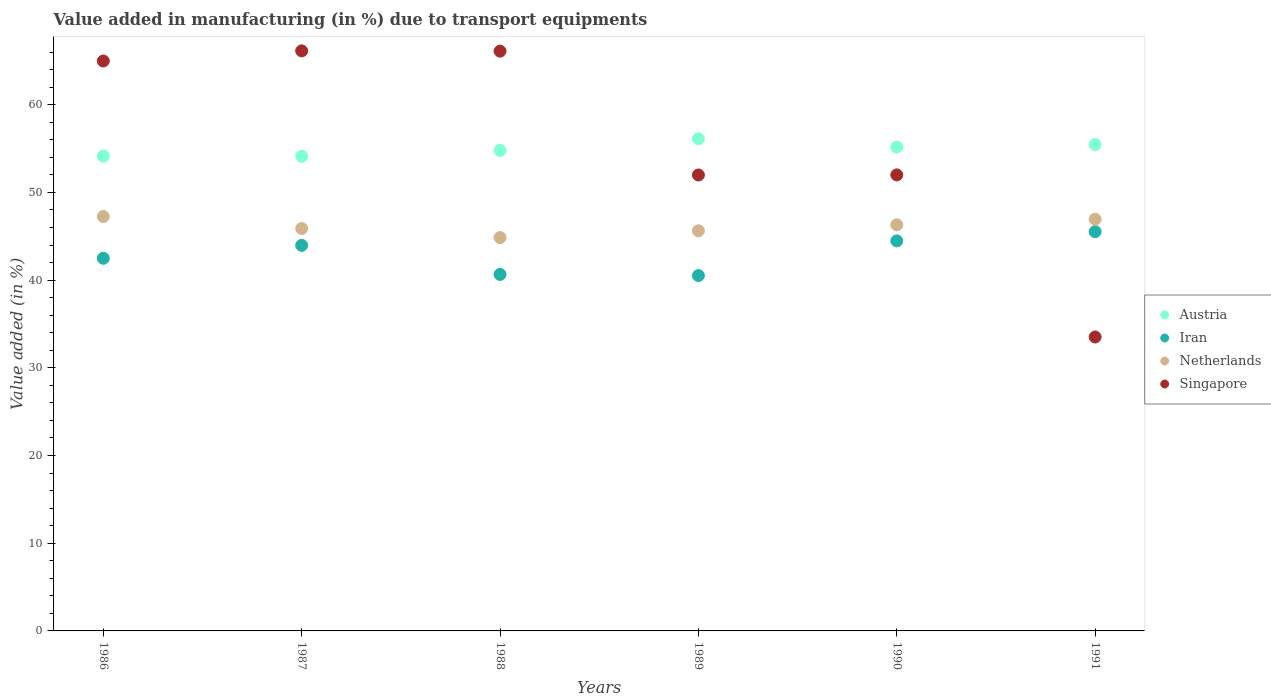What is the percentage of value added in manufacturing due to transport equipments in Austria in 1988?
Ensure brevity in your answer.  54.79. Across all years, what is the maximum percentage of value added in manufacturing due to transport equipments in Netherlands?
Give a very brief answer. 47.25. Across all years, what is the minimum percentage of value added in manufacturing due to transport equipments in Singapore?
Your answer should be compact. 33.51. What is the total percentage of value added in manufacturing due to transport equipments in Netherlands in the graph?
Provide a succinct answer. 276.85. What is the difference between the percentage of value added in manufacturing due to transport equipments in Iran in 1988 and that in 1991?
Your response must be concise. -4.87. What is the difference between the percentage of value added in manufacturing due to transport equipments in Netherlands in 1991 and the percentage of value added in manufacturing due to transport equipments in Iran in 1989?
Provide a succinct answer. 6.42. What is the average percentage of value added in manufacturing due to transport equipments in Iran per year?
Your response must be concise. 42.94. In the year 1986, what is the difference between the percentage of value added in manufacturing due to transport equipments in Singapore and percentage of value added in manufacturing due to transport equipments in Austria?
Give a very brief answer. 10.84. What is the ratio of the percentage of value added in manufacturing due to transport equipments in Singapore in 1989 to that in 1991?
Give a very brief answer. 1.55. Is the percentage of value added in manufacturing due to transport equipments in Netherlands in 1987 less than that in 1989?
Offer a very short reply. No. What is the difference between the highest and the second highest percentage of value added in manufacturing due to transport equipments in Netherlands?
Provide a succinct answer. 0.32. What is the difference between the highest and the lowest percentage of value added in manufacturing due to transport equipments in Singapore?
Ensure brevity in your answer.  32.62. Is the sum of the percentage of value added in manufacturing due to transport equipments in Netherlands in 1986 and 1989 greater than the maximum percentage of value added in manufacturing due to transport equipments in Austria across all years?
Offer a very short reply. Yes. Is it the case that in every year, the sum of the percentage of value added in manufacturing due to transport equipments in Netherlands and percentage of value added in manufacturing due to transport equipments in Singapore  is greater than the sum of percentage of value added in manufacturing due to transport equipments in Iran and percentage of value added in manufacturing due to transport equipments in Austria?
Your answer should be compact. No. Is it the case that in every year, the sum of the percentage of value added in manufacturing due to transport equipments in Netherlands and percentage of value added in manufacturing due to transport equipments in Austria  is greater than the percentage of value added in manufacturing due to transport equipments in Singapore?
Offer a very short reply. Yes. Is the percentage of value added in manufacturing due to transport equipments in Austria strictly less than the percentage of value added in manufacturing due to transport equipments in Netherlands over the years?
Give a very brief answer. No. How many dotlines are there?
Your response must be concise. 4. What is the difference between two consecutive major ticks on the Y-axis?
Offer a terse response. 10. Does the graph contain any zero values?
Offer a very short reply. No. How are the legend labels stacked?
Give a very brief answer. Vertical. What is the title of the graph?
Provide a succinct answer. Value added in manufacturing (in %) due to transport equipments. Does "High income" appear as one of the legend labels in the graph?
Your answer should be very brief. No. What is the label or title of the X-axis?
Provide a short and direct response. Years. What is the label or title of the Y-axis?
Keep it short and to the point. Value added (in %). What is the Value added (in %) of Austria in 1986?
Your answer should be very brief. 54.14. What is the Value added (in %) of Iran in 1986?
Ensure brevity in your answer.  42.49. What is the Value added (in %) of Netherlands in 1986?
Offer a terse response. 47.25. What is the Value added (in %) of Singapore in 1986?
Give a very brief answer. 64.98. What is the Value added (in %) of Austria in 1987?
Provide a succinct answer. 54.12. What is the Value added (in %) in Iran in 1987?
Your response must be concise. 43.96. What is the Value added (in %) of Netherlands in 1987?
Make the answer very short. 45.88. What is the Value added (in %) of Singapore in 1987?
Ensure brevity in your answer.  66.14. What is the Value added (in %) in Austria in 1988?
Your answer should be compact. 54.79. What is the Value added (in %) of Iran in 1988?
Your answer should be very brief. 40.65. What is the Value added (in %) in Netherlands in 1988?
Make the answer very short. 44.85. What is the Value added (in %) in Singapore in 1988?
Your response must be concise. 66.11. What is the Value added (in %) of Austria in 1989?
Offer a terse response. 56.11. What is the Value added (in %) of Iran in 1989?
Provide a short and direct response. 40.52. What is the Value added (in %) of Netherlands in 1989?
Your answer should be compact. 45.63. What is the Value added (in %) of Singapore in 1989?
Make the answer very short. 51.99. What is the Value added (in %) in Austria in 1990?
Offer a terse response. 55.17. What is the Value added (in %) of Iran in 1990?
Your response must be concise. 44.48. What is the Value added (in %) of Netherlands in 1990?
Make the answer very short. 46.31. What is the Value added (in %) of Singapore in 1990?
Your answer should be compact. 52. What is the Value added (in %) of Austria in 1991?
Offer a terse response. 55.46. What is the Value added (in %) of Iran in 1991?
Ensure brevity in your answer.  45.52. What is the Value added (in %) of Netherlands in 1991?
Your answer should be very brief. 46.94. What is the Value added (in %) of Singapore in 1991?
Make the answer very short. 33.51. Across all years, what is the maximum Value added (in %) in Austria?
Your response must be concise. 56.11. Across all years, what is the maximum Value added (in %) in Iran?
Offer a very short reply. 45.52. Across all years, what is the maximum Value added (in %) in Netherlands?
Provide a succinct answer. 47.25. Across all years, what is the maximum Value added (in %) of Singapore?
Make the answer very short. 66.14. Across all years, what is the minimum Value added (in %) of Austria?
Offer a terse response. 54.12. Across all years, what is the minimum Value added (in %) of Iran?
Make the answer very short. 40.52. Across all years, what is the minimum Value added (in %) of Netherlands?
Provide a succinct answer. 44.85. Across all years, what is the minimum Value added (in %) of Singapore?
Your answer should be very brief. 33.51. What is the total Value added (in %) of Austria in the graph?
Provide a short and direct response. 329.79. What is the total Value added (in %) of Iran in the graph?
Provide a succinct answer. 257.62. What is the total Value added (in %) in Netherlands in the graph?
Make the answer very short. 276.85. What is the total Value added (in %) in Singapore in the graph?
Give a very brief answer. 334.73. What is the difference between the Value added (in %) in Austria in 1986 and that in 1987?
Offer a terse response. 0.02. What is the difference between the Value added (in %) in Iran in 1986 and that in 1987?
Give a very brief answer. -1.47. What is the difference between the Value added (in %) in Netherlands in 1986 and that in 1987?
Offer a terse response. 1.37. What is the difference between the Value added (in %) in Singapore in 1986 and that in 1987?
Your answer should be very brief. -1.15. What is the difference between the Value added (in %) in Austria in 1986 and that in 1988?
Your answer should be very brief. -0.64. What is the difference between the Value added (in %) of Iran in 1986 and that in 1988?
Your answer should be compact. 1.84. What is the difference between the Value added (in %) of Netherlands in 1986 and that in 1988?
Make the answer very short. 2.41. What is the difference between the Value added (in %) in Singapore in 1986 and that in 1988?
Your answer should be very brief. -1.13. What is the difference between the Value added (in %) of Austria in 1986 and that in 1989?
Offer a terse response. -1.97. What is the difference between the Value added (in %) of Iran in 1986 and that in 1989?
Your response must be concise. 1.97. What is the difference between the Value added (in %) in Netherlands in 1986 and that in 1989?
Provide a succinct answer. 1.63. What is the difference between the Value added (in %) of Singapore in 1986 and that in 1989?
Provide a succinct answer. 13. What is the difference between the Value added (in %) of Austria in 1986 and that in 1990?
Provide a short and direct response. -1.03. What is the difference between the Value added (in %) in Iran in 1986 and that in 1990?
Your answer should be compact. -1.99. What is the difference between the Value added (in %) of Netherlands in 1986 and that in 1990?
Make the answer very short. 0.95. What is the difference between the Value added (in %) of Singapore in 1986 and that in 1990?
Keep it short and to the point. 12.99. What is the difference between the Value added (in %) in Austria in 1986 and that in 1991?
Ensure brevity in your answer.  -1.31. What is the difference between the Value added (in %) of Iran in 1986 and that in 1991?
Provide a succinct answer. -3.03. What is the difference between the Value added (in %) of Netherlands in 1986 and that in 1991?
Ensure brevity in your answer.  0.32. What is the difference between the Value added (in %) of Singapore in 1986 and that in 1991?
Give a very brief answer. 31.47. What is the difference between the Value added (in %) in Austria in 1987 and that in 1988?
Your answer should be very brief. -0.67. What is the difference between the Value added (in %) in Iran in 1987 and that in 1988?
Offer a terse response. 3.31. What is the difference between the Value added (in %) of Netherlands in 1987 and that in 1988?
Make the answer very short. 1.03. What is the difference between the Value added (in %) in Singapore in 1987 and that in 1988?
Offer a very short reply. 0.03. What is the difference between the Value added (in %) of Austria in 1987 and that in 1989?
Offer a terse response. -1.99. What is the difference between the Value added (in %) in Iran in 1987 and that in 1989?
Keep it short and to the point. 3.44. What is the difference between the Value added (in %) in Netherlands in 1987 and that in 1989?
Provide a short and direct response. 0.26. What is the difference between the Value added (in %) in Singapore in 1987 and that in 1989?
Offer a very short reply. 14.15. What is the difference between the Value added (in %) in Austria in 1987 and that in 1990?
Provide a succinct answer. -1.05. What is the difference between the Value added (in %) in Iran in 1987 and that in 1990?
Your response must be concise. -0.51. What is the difference between the Value added (in %) of Netherlands in 1987 and that in 1990?
Make the answer very short. -0.43. What is the difference between the Value added (in %) in Singapore in 1987 and that in 1990?
Provide a short and direct response. 14.14. What is the difference between the Value added (in %) of Austria in 1987 and that in 1991?
Give a very brief answer. -1.34. What is the difference between the Value added (in %) in Iran in 1987 and that in 1991?
Keep it short and to the point. -1.56. What is the difference between the Value added (in %) in Netherlands in 1987 and that in 1991?
Make the answer very short. -1.06. What is the difference between the Value added (in %) of Singapore in 1987 and that in 1991?
Provide a succinct answer. 32.62. What is the difference between the Value added (in %) of Austria in 1988 and that in 1989?
Keep it short and to the point. -1.32. What is the difference between the Value added (in %) of Iran in 1988 and that in 1989?
Give a very brief answer. 0.13. What is the difference between the Value added (in %) in Netherlands in 1988 and that in 1989?
Provide a succinct answer. -0.78. What is the difference between the Value added (in %) of Singapore in 1988 and that in 1989?
Offer a terse response. 14.12. What is the difference between the Value added (in %) of Austria in 1988 and that in 1990?
Ensure brevity in your answer.  -0.38. What is the difference between the Value added (in %) in Iran in 1988 and that in 1990?
Your answer should be compact. -3.83. What is the difference between the Value added (in %) in Netherlands in 1988 and that in 1990?
Make the answer very short. -1.46. What is the difference between the Value added (in %) in Singapore in 1988 and that in 1990?
Your answer should be compact. 14.11. What is the difference between the Value added (in %) in Austria in 1988 and that in 1991?
Your answer should be very brief. -0.67. What is the difference between the Value added (in %) of Iran in 1988 and that in 1991?
Give a very brief answer. -4.87. What is the difference between the Value added (in %) of Netherlands in 1988 and that in 1991?
Keep it short and to the point. -2.09. What is the difference between the Value added (in %) of Singapore in 1988 and that in 1991?
Your response must be concise. 32.6. What is the difference between the Value added (in %) in Austria in 1989 and that in 1990?
Give a very brief answer. 0.94. What is the difference between the Value added (in %) of Iran in 1989 and that in 1990?
Provide a succinct answer. -3.96. What is the difference between the Value added (in %) of Netherlands in 1989 and that in 1990?
Offer a very short reply. -0.68. What is the difference between the Value added (in %) in Singapore in 1989 and that in 1990?
Offer a terse response. -0.01. What is the difference between the Value added (in %) in Austria in 1989 and that in 1991?
Provide a succinct answer. 0.65. What is the difference between the Value added (in %) of Iran in 1989 and that in 1991?
Your answer should be very brief. -5. What is the difference between the Value added (in %) in Netherlands in 1989 and that in 1991?
Ensure brevity in your answer.  -1.31. What is the difference between the Value added (in %) in Singapore in 1989 and that in 1991?
Provide a succinct answer. 18.47. What is the difference between the Value added (in %) in Austria in 1990 and that in 1991?
Your response must be concise. -0.29. What is the difference between the Value added (in %) of Iran in 1990 and that in 1991?
Make the answer very short. -1.05. What is the difference between the Value added (in %) in Netherlands in 1990 and that in 1991?
Provide a short and direct response. -0.63. What is the difference between the Value added (in %) in Singapore in 1990 and that in 1991?
Make the answer very short. 18.48. What is the difference between the Value added (in %) of Austria in 1986 and the Value added (in %) of Iran in 1987?
Your response must be concise. 10.18. What is the difference between the Value added (in %) of Austria in 1986 and the Value added (in %) of Netherlands in 1987?
Your answer should be compact. 8.26. What is the difference between the Value added (in %) in Austria in 1986 and the Value added (in %) in Singapore in 1987?
Keep it short and to the point. -11.99. What is the difference between the Value added (in %) in Iran in 1986 and the Value added (in %) in Netherlands in 1987?
Your response must be concise. -3.39. What is the difference between the Value added (in %) of Iran in 1986 and the Value added (in %) of Singapore in 1987?
Provide a succinct answer. -23.65. What is the difference between the Value added (in %) in Netherlands in 1986 and the Value added (in %) in Singapore in 1987?
Offer a very short reply. -18.89. What is the difference between the Value added (in %) of Austria in 1986 and the Value added (in %) of Iran in 1988?
Ensure brevity in your answer.  13.49. What is the difference between the Value added (in %) of Austria in 1986 and the Value added (in %) of Netherlands in 1988?
Keep it short and to the point. 9.3. What is the difference between the Value added (in %) of Austria in 1986 and the Value added (in %) of Singapore in 1988?
Ensure brevity in your answer.  -11.97. What is the difference between the Value added (in %) in Iran in 1986 and the Value added (in %) in Netherlands in 1988?
Provide a succinct answer. -2.36. What is the difference between the Value added (in %) of Iran in 1986 and the Value added (in %) of Singapore in 1988?
Your response must be concise. -23.62. What is the difference between the Value added (in %) in Netherlands in 1986 and the Value added (in %) in Singapore in 1988?
Your answer should be very brief. -18.86. What is the difference between the Value added (in %) in Austria in 1986 and the Value added (in %) in Iran in 1989?
Your answer should be very brief. 13.63. What is the difference between the Value added (in %) in Austria in 1986 and the Value added (in %) in Netherlands in 1989?
Your answer should be compact. 8.52. What is the difference between the Value added (in %) of Austria in 1986 and the Value added (in %) of Singapore in 1989?
Give a very brief answer. 2.16. What is the difference between the Value added (in %) in Iran in 1986 and the Value added (in %) in Netherlands in 1989?
Offer a very short reply. -3.14. What is the difference between the Value added (in %) of Iran in 1986 and the Value added (in %) of Singapore in 1989?
Provide a succinct answer. -9.5. What is the difference between the Value added (in %) in Netherlands in 1986 and the Value added (in %) in Singapore in 1989?
Give a very brief answer. -4.73. What is the difference between the Value added (in %) of Austria in 1986 and the Value added (in %) of Iran in 1990?
Keep it short and to the point. 9.67. What is the difference between the Value added (in %) in Austria in 1986 and the Value added (in %) in Netherlands in 1990?
Offer a very short reply. 7.84. What is the difference between the Value added (in %) in Austria in 1986 and the Value added (in %) in Singapore in 1990?
Offer a terse response. 2.15. What is the difference between the Value added (in %) in Iran in 1986 and the Value added (in %) in Netherlands in 1990?
Offer a very short reply. -3.82. What is the difference between the Value added (in %) in Iran in 1986 and the Value added (in %) in Singapore in 1990?
Offer a very short reply. -9.51. What is the difference between the Value added (in %) in Netherlands in 1986 and the Value added (in %) in Singapore in 1990?
Provide a succinct answer. -4.75. What is the difference between the Value added (in %) of Austria in 1986 and the Value added (in %) of Iran in 1991?
Your response must be concise. 8.62. What is the difference between the Value added (in %) of Austria in 1986 and the Value added (in %) of Netherlands in 1991?
Ensure brevity in your answer.  7.21. What is the difference between the Value added (in %) in Austria in 1986 and the Value added (in %) in Singapore in 1991?
Offer a terse response. 20.63. What is the difference between the Value added (in %) in Iran in 1986 and the Value added (in %) in Netherlands in 1991?
Make the answer very short. -4.45. What is the difference between the Value added (in %) of Iran in 1986 and the Value added (in %) of Singapore in 1991?
Offer a terse response. 8.97. What is the difference between the Value added (in %) in Netherlands in 1986 and the Value added (in %) in Singapore in 1991?
Provide a short and direct response. 13.74. What is the difference between the Value added (in %) of Austria in 1987 and the Value added (in %) of Iran in 1988?
Make the answer very short. 13.47. What is the difference between the Value added (in %) in Austria in 1987 and the Value added (in %) in Netherlands in 1988?
Your response must be concise. 9.27. What is the difference between the Value added (in %) of Austria in 1987 and the Value added (in %) of Singapore in 1988?
Your response must be concise. -11.99. What is the difference between the Value added (in %) of Iran in 1987 and the Value added (in %) of Netherlands in 1988?
Provide a short and direct response. -0.89. What is the difference between the Value added (in %) of Iran in 1987 and the Value added (in %) of Singapore in 1988?
Give a very brief answer. -22.15. What is the difference between the Value added (in %) of Netherlands in 1987 and the Value added (in %) of Singapore in 1988?
Offer a very short reply. -20.23. What is the difference between the Value added (in %) in Austria in 1987 and the Value added (in %) in Iran in 1989?
Make the answer very short. 13.6. What is the difference between the Value added (in %) in Austria in 1987 and the Value added (in %) in Netherlands in 1989?
Provide a succinct answer. 8.5. What is the difference between the Value added (in %) of Austria in 1987 and the Value added (in %) of Singapore in 1989?
Ensure brevity in your answer.  2.13. What is the difference between the Value added (in %) of Iran in 1987 and the Value added (in %) of Netherlands in 1989?
Offer a very short reply. -1.66. What is the difference between the Value added (in %) in Iran in 1987 and the Value added (in %) in Singapore in 1989?
Offer a terse response. -8.02. What is the difference between the Value added (in %) in Netherlands in 1987 and the Value added (in %) in Singapore in 1989?
Offer a very short reply. -6.11. What is the difference between the Value added (in %) of Austria in 1987 and the Value added (in %) of Iran in 1990?
Your answer should be very brief. 9.65. What is the difference between the Value added (in %) in Austria in 1987 and the Value added (in %) in Netherlands in 1990?
Your response must be concise. 7.81. What is the difference between the Value added (in %) of Austria in 1987 and the Value added (in %) of Singapore in 1990?
Make the answer very short. 2.12. What is the difference between the Value added (in %) of Iran in 1987 and the Value added (in %) of Netherlands in 1990?
Provide a short and direct response. -2.34. What is the difference between the Value added (in %) of Iran in 1987 and the Value added (in %) of Singapore in 1990?
Ensure brevity in your answer.  -8.04. What is the difference between the Value added (in %) in Netherlands in 1987 and the Value added (in %) in Singapore in 1990?
Your answer should be compact. -6.12. What is the difference between the Value added (in %) in Austria in 1987 and the Value added (in %) in Iran in 1991?
Your response must be concise. 8.6. What is the difference between the Value added (in %) in Austria in 1987 and the Value added (in %) in Netherlands in 1991?
Your answer should be very brief. 7.18. What is the difference between the Value added (in %) of Austria in 1987 and the Value added (in %) of Singapore in 1991?
Provide a short and direct response. 20.61. What is the difference between the Value added (in %) in Iran in 1987 and the Value added (in %) in Netherlands in 1991?
Offer a terse response. -2.97. What is the difference between the Value added (in %) in Iran in 1987 and the Value added (in %) in Singapore in 1991?
Your answer should be very brief. 10.45. What is the difference between the Value added (in %) of Netherlands in 1987 and the Value added (in %) of Singapore in 1991?
Ensure brevity in your answer.  12.37. What is the difference between the Value added (in %) of Austria in 1988 and the Value added (in %) of Iran in 1989?
Offer a terse response. 14.27. What is the difference between the Value added (in %) in Austria in 1988 and the Value added (in %) in Netherlands in 1989?
Offer a very short reply. 9.16. What is the difference between the Value added (in %) of Austria in 1988 and the Value added (in %) of Singapore in 1989?
Keep it short and to the point. 2.8. What is the difference between the Value added (in %) of Iran in 1988 and the Value added (in %) of Netherlands in 1989?
Provide a succinct answer. -4.97. What is the difference between the Value added (in %) in Iran in 1988 and the Value added (in %) in Singapore in 1989?
Your response must be concise. -11.34. What is the difference between the Value added (in %) in Netherlands in 1988 and the Value added (in %) in Singapore in 1989?
Your answer should be very brief. -7.14. What is the difference between the Value added (in %) in Austria in 1988 and the Value added (in %) in Iran in 1990?
Offer a terse response. 10.31. What is the difference between the Value added (in %) in Austria in 1988 and the Value added (in %) in Netherlands in 1990?
Your answer should be very brief. 8.48. What is the difference between the Value added (in %) of Austria in 1988 and the Value added (in %) of Singapore in 1990?
Offer a very short reply. 2.79. What is the difference between the Value added (in %) in Iran in 1988 and the Value added (in %) in Netherlands in 1990?
Offer a terse response. -5.66. What is the difference between the Value added (in %) in Iran in 1988 and the Value added (in %) in Singapore in 1990?
Keep it short and to the point. -11.35. What is the difference between the Value added (in %) in Netherlands in 1988 and the Value added (in %) in Singapore in 1990?
Ensure brevity in your answer.  -7.15. What is the difference between the Value added (in %) of Austria in 1988 and the Value added (in %) of Iran in 1991?
Ensure brevity in your answer.  9.27. What is the difference between the Value added (in %) in Austria in 1988 and the Value added (in %) in Netherlands in 1991?
Make the answer very short. 7.85. What is the difference between the Value added (in %) of Austria in 1988 and the Value added (in %) of Singapore in 1991?
Offer a terse response. 21.27. What is the difference between the Value added (in %) of Iran in 1988 and the Value added (in %) of Netherlands in 1991?
Give a very brief answer. -6.29. What is the difference between the Value added (in %) of Iran in 1988 and the Value added (in %) of Singapore in 1991?
Keep it short and to the point. 7.14. What is the difference between the Value added (in %) in Netherlands in 1988 and the Value added (in %) in Singapore in 1991?
Your answer should be very brief. 11.33. What is the difference between the Value added (in %) in Austria in 1989 and the Value added (in %) in Iran in 1990?
Offer a terse response. 11.64. What is the difference between the Value added (in %) of Austria in 1989 and the Value added (in %) of Netherlands in 1990?
Offer a very short reply. 9.8. What is the difference between the Value added (in %) of Austria in 1989 and the Value added (in %) of Singapore in 1990?
Your answer should be compact. 4.11. What is the difference between the Value added (in %) of Iran in 1989 and the Value added (in %) of Netherlands in 1990?
Your answer should be compact. -5.79. What is the difference between the Value added (in %) in Iran in 1989 and the Value added (in %) in Singapore in 1990?
Keep it short and to the point. -11.48. What is the difference between the Value added (in %) in Netherlands in 1989 and the Value added (in %) in Singapore in 1990?
Your answer should be compact. -6.37. What is the difference between the Value added (in %) of Austria in 1989 and the Value added (in %) of Iran in 1991?
Your answer should be compact. 10.59. What is the difference between the Value added (in %) in Austria in 1989 and the Value added (in %) in Netherlands in 1991?
Keep it short and to the point. 9.17. What is the difference between the Value added (in %) in Austria in 1989 and the Value added (in %) in Singapore in 1991?
Provide a succinct answer. 22.6. What is the difference between the Value added (in %) in Iran in 1989 and the Value added (in %) in Netherlands in 1991?
Your answer should be compact. -6.42. What is the difference between the Value added (in %) in Iran in 1989 and the Value added (in %) in Singapore in 1991?
Your answer should be very brief. 7. What is the difference between the Value added (in %) of Netherlands in 1989 and the Value added (in %) of Singapore in 1991?
Provide a short and direct response. 12.11. What is the difference between the Value added (in %) in Austria in 1990 and the Value added (in %) in Iran in 1991?
Make the answer very short. 9.65. What is the difference between the Value added (in %) of Austria in 1990 and the Value added (in %) of Netherlands in 1991?
Your answer should be very brief. 8.23. What is the difference between the Value added (in %) in Austria in 1990 and the Value added (in %) in Singapore in 1991?
Provide a short and direct response. 21.66. What is the difference between the Value added (in %) of Iran in 1990 and the Value added (in %) of Netherlands in 1991?
Your answer should be very brief. -2.46. What is the difference between the Value added (in %) of Iran in 1990 and the Value added (in %) of Singapore in 1991?
Make the answer very short. 10.96. What is the difference between the Value added (in %) in Netherlands in 1990 and the Value added (in %) in Singapore in 1991?
Your response must be concise. 12.79. What is the average Value added (in %) of Austria per year?
Keep it short and to the point. 54.97. What is the average Value added (in %) in Iran per year?
Offer a terse response. 42.94. What is the average Value added (in %) of Netherlands per year?
Offer a very short reply. 46.14. What is the average Value added (in %) in Singapore per year?
Your response must be concise. 55.79. In the year 1986, what is the difference between the Value added (in %) of Austria and Value added (in %) of Iran?
Provide a short and direct response. 11.66. In the year 1986, what is the difference between the Value added (in %) in Austria and Value added (in %) in Netherlands?
Offer a terse response. 6.89. In the year 1986, what is the difference between the Value added (in %) of Austria and Value added (in %) of Singapore?
Provide a succinct answer. -10.84. In the year 1986, what is the difference between the Value added (in %) of Iran and Value added (in %) of Netherlands?
Offer a terse response. -4.76. In the year 1986, what is the difference between the Value added (in %) in Iran and Value added (in %) in Singapore?
Make the answer very short. -22.5. In the year 1986, what is the difference between the Value added (in %) in Netherlands and Value added (in %) in Singapore?
Your answer should be compact. -17.73. In the year 1987, what is the difference between the Value added (in %) in Austria and Value added (in %) in Iran?
Give a very brief answer. 10.16. In the year 1987, what is the difference between the Value added (in %) of Austria and Value added (in %) of Netherlands?
Ensure brevity in your answer.  8.24. In the year 1987, what is the difference between the Value added (in %) in Austria and Value added (in %) in Singapore?
Give a very brief answer. -12.02. In the year 1987, what is the difference between the Value added (in %) in Iran and Value added (in %) in Netherlands?
Make the answer very short. -1.92. In the year 1987, what is the difference between the Value added (in %) in Iran and Value added (in %) in Singapore?
Make the answer very short. -22.18. In the year 1987, what is the difference between the Value added (in %) in Netherlands and Value added (in %) in Singapore?
Offer a terse response. -20.26. In the year 1988, what is the difference between the Value added (in %) of Austria and Value added (in %) of Iran?
Offer a terse response. 14.14. In the year 1988, what is the difference between the Value added (in %) of Austria and Value added (in %) of Netherlands?
Offer a terse response. 9.94. In the year 1988, what is the difference between the Value added (in %) in Austria and Value added (in %) in Singapore?
Your answer should be compact. -11.32. In the year 1988, what is the difference between the Value added (in %) in Iran and Value added (in %) in Netherlands?
Give a very brief answer. -4.2. In the year 1988, what is the difference between the Value added (in %) in Iran and Value added (in %) in Singapore?
Give a very brief answer. -25.46. In the year 1988, what is the difference between the Value added (in %) of Netherlands and Value added (in %) of Singapore?
Offer a terse response. -21.26. In the year 1989, what is the difference between the Value added (in %) of Austria and Value added (in %) of Iran?
Offer a very short reply. 15.59. In the year 1989, what is the difference between the Value added (in %) of Austria and Value added (in %) of Netherlands?
Offer a terse response. 10.49. In the year 1989, what is the difference between the Value added (in %) of Austria and Value added (in %) of Singapore?
Provide a short and direct response. 4.13. In the year 1989, what is the difference between the Value added (in %) of Iran and Value added (in %) of Netherlands?
Provide a short and direct response. -5.11. In the year 1989, what is the difference between the Value added (in %) of Iran and Value added (in %) of Singapore?
Make the answer very short. -11.47. In the year 1989, what is the difference between the Value added (in %) of Netherlands and Value added (in %) of Singapore?
Your answer should be very brief. -6.36. In the year 1990, what is the difference between the Value added (in %) of Austria and Value added (in %) of Iran?
Your answer should be compact. 10.7. In the year 1990, what is the difference between the Value added (in %) of Austria and Value added (in %) of Netherlands?
Your answer should be compact. 8.87. In the year 1990, what is the difference between the Value added (in %) of Austria and Value added (in %) of Singapore?
Your answer should be very brief. 3.17. In the year 1990, what is the difference between the Value added (in %) of Iran and Value added (in %) of Netherlands?
Provide a succinct answer. -1.83. In the year 1990, what is the difference between the Value added (in %) of Iran and Value added (in %) of Singapore?
Offer a very short reply. -7.52. In the year 1990, what is the difference between the Value added (in %) of Netherlands and Value added (in %) of Singapore?
Ensure brevity in your answer.  -5.69. In the year 1991, what is the difference between the Value added (in %) of Austria and Value added (in %) of Iran?
Ensure brevity in your answer.  9.94. In the year 1991, what is the difference between the Value added (in %) in Austria and Value added (in %) in Netherlands?
Provide a succinct answer. 8.52. In the year 1991, what is the difference between the Value added (in %) of Austria and Value added (in %) of Singapore?
Make the answer very short. 21.94. In the year 1991, what is the difference between the Value added (in %) of Iran and Value added (in %) of Netherlands?
Ensure brevity in your answer.  -1.42. In the year 1991, what is the difference between the Value added (in %) of Iran and Value added (in %) of Singapore?
Your response must be concise. 12.01. In the year 1991, what is the difference between the Value added (in %) in Netherlands and Value added (in %) in Singapore?
Provide a succinct answer. 13.42. What is the ratio of the Value added (in %) in Austria in 1986 to that in 1987?
Offer a terse response. 1. What is the ratio of the Value added (in %) of Iran in 1986 to that in 1987?
Make the answer very short. 0.97. What is the ratio of the Value added (in %) in Netherlands in 1986 to that in 1987?
Ensure brevity in your answer.  1.03. What is the ratio of the Value added (in %) in Singapore in 1986 to that in 1987?
Your response must be concise. 0.98. What is the ratio of the Value added (in %) of Austria in 1986 to that in 1988?
Your answer should be compact. 0.99. What is the ratio of the Value added (in %) in Iran in 1986 to that in 1988?
Provide a short and direct response. 1.05. What is the ratio of the Value added (in %) of Netherlands in 1986 to that in 1988?
Offer a very short reply. 1.05. What is the ratio of the Value added (in %) in Singapore in 1986 to that in 1988?
Offer a very short reply. 0.98. What is the ratio of the Value added (in %) in Austria in 1986 to that in 1989?
Provide a succinct answer. 0.96. What is the ratio of the Value added (in %) of Iran in 1986 to that in 1989?
Keep it short and to the point. 1.05. What is the ratio of the Value added (in %) of Netherlands in 1986 to that in 1989?
Give a very brief answer. 1.04. What is the ratio of the Value added (in %) in Austria in 1986 to that in 1990?
Offer a very short reply. 0.98. What is the ratio of the Value added (in %) of Iran in 1986 to that in 1990?
Your answer should be compact. 0.96. What is the ratio of the Value added (in %) of Netherlands in 1986 to that in 1990?
Offer a very short reply. 1.02. What is the ratio of the Value added (in %) of Singapore in 1986 to that in 1990?
Your response must be concise. 1.25. What is the ratio of the Value added (in %) of Austria in 1986 to that in 1991?
Offer a very short reply. 0.98. What is the ratio of the Value added (in %) of Iran in 1986 to that in 1991?
Offer a very short reply. 0.93. What is the ratio of the Value added (in %) in Singapore in 1986 to that in 1991?
Offer a very short reply. 1.94. What is the ratio of the Value added (in %) of Austria in 1987 to that in 1988?
Offer a terse response. 0.99. What is the ratio of the Value added (in %) of Iran in 1987 to that in 1988?
Make the answer very short. 1.08. What is the ratio of the Value added (in %) of Singapore in 1987 to that in 1988?
Your answer should be compact. 1. What is the ratio of the Value added (in %) in Austria in 1987 to that in 1989?
Provide a succinct answer. 0.96. What is the ratio of the Value added (in %) of Iran in 1987 to that in 1989?
Offer a very short reply. 1.08. What is the ratio of the Value added (in %) in Netherlands in 1987 to that in 1989?
Offer a very short reply. 1.01. What is the ratio of the Value added (in %) in Singapore in 1987 to that in 1989?
Your answer should be very brief. 1.27. What is the ratio of the Value added (in %) in Austria in 1987 to that in 1990?
Keep it short and to the point. 0.98. What is the ratio of the Value added (in %) in Iran in 1987 to that in 1990?
Offer a very short reply. 0.99. What is the ratio of the Value added (in %) in Singapore in 1987 to that in 1990?
Your answer should be compact. 1.27. What is the ratio of the Value added (in %) in Austria in 1987 to that in 1991?
Your response must be concise. 0.98. What is the ratio of the Value added (in %) of Iran in 1987 to that in 1991?
Offer a very short reply. 0.97. What is the ratio of the Value added (in %) of Netherlands in 1987 to that in 1991?
Keep it short and to the point. 0.98. What is the ratio of the Value added (in %) in Singapore in 1987 to that in 1991?
Make the answer very short. 1.97. What is the ratio of the Value added (in %) of Austria in 1988 to that in 1989?
Provide a short and direct response. 0.98. What is the ratio of the Value added (in %) in Singapore in 1988 to that in 1989?
Give a very brief answer. 1.27. What is the ratio of the Value added (in %) in Iran in 1988 to that in 1990?
Keep it short and to the point. 0.91. What is the ratio of the Value added (in %) in Netherlands in 1988 to that in 1990?
Ensure brevity in your answer.  0.97. What is the ratio of the Value added (in %) of Singapore in 1988 to that in 1990?
Provide a short and direct response. 1.27. What is the ratio of the Value added (in %) in Austria in 1988 to that in 1991?
Provide a succinct answer. 0.99. What is the ratio of the Value added (in %) in Iran in 1988 to that in 1991?
Ensure brevity in your answer.  0.89. What is the ratio of the Value added (in %) of Netherlands in 1988 to that in 1991?
Offer a very short reply. 0.96. What is the ratio of the Value added (in %) of Singapore in 1988 to that in 1991?
Offer a very short reply. 1.97. What is the ratio of the Value added (in %) in Austria in 1989 to that in 1990?
Make the answer very short. 1.02. What is the ratio of the Value added (in %) in Iran in 1989 to that in 1990?
Your answer should be very brief. 0.91. What is the ratio of the Value added (in %) of Netherlands in 1989 to that in 1990?
Your response must be concise. 0.99. What is the ratio of the Value added (in %) of Singapore in 1989 to that in 1990?
Offer a very short reply. 1. What is the ratio of the Value added (in %) of Austria in 1989 to that in 1991?
Give a very brief answer. 1.01. What is the ratio of the Value added (in %) in Iran in 1989 to that in 1991?
Ensure brevity in your answer.  0.89. What is the ratio of the Value added (in %) in Singapore in 1989 to that in 1991?
Give a very brief answer. 1.55. What is the ratio of the Value added (in %) of Austria in 1990 to that in 1991?
Your answer should be compact. 0.99. What is the ratio of the Value added (in %) in Iran in 1990 to that in 1991?
Provide a short and direct response. 0.98. What is the ratio of the Value added (in %) of Netherlands in 1990 to that in 1991?
Make the answer very short. 0.99. What is the ratio of the Value added (in %) in Singapore in 1990 to that in 1991?
Provide a succinct answer. 1.55. What is the difference between the highest and the second highest Value added (in %) of Austria?
Your answer should be compact. 0.65. What is the difference between the highest and the second highest Value added (in %) in Iran?
Offer a very short reply. 1.05. What is the difference between the highest and the second highest Value added (in %) in Netherlands?
Your answer should be very brief. 0.32. What is the difference between the highest and the second highest Value added (in %) in Singapore?
Provide a short and direct response. 0.03. What is the difference between the highest and the lowest Value added (in %) of Austria?
Provide a short and direct response. 1.99. What is the difference between the highest and the lowest Value added (in %) of Iran?
Ensure brevity in your answer.  5. What is the difference between the highest and the lowest Value added (in %) of Netherlands?
Your response must be concise. 2.41. What is the difference between the highest and the lowest Value added (in %) of Singapore?
Your response must be concise. 32.62. 